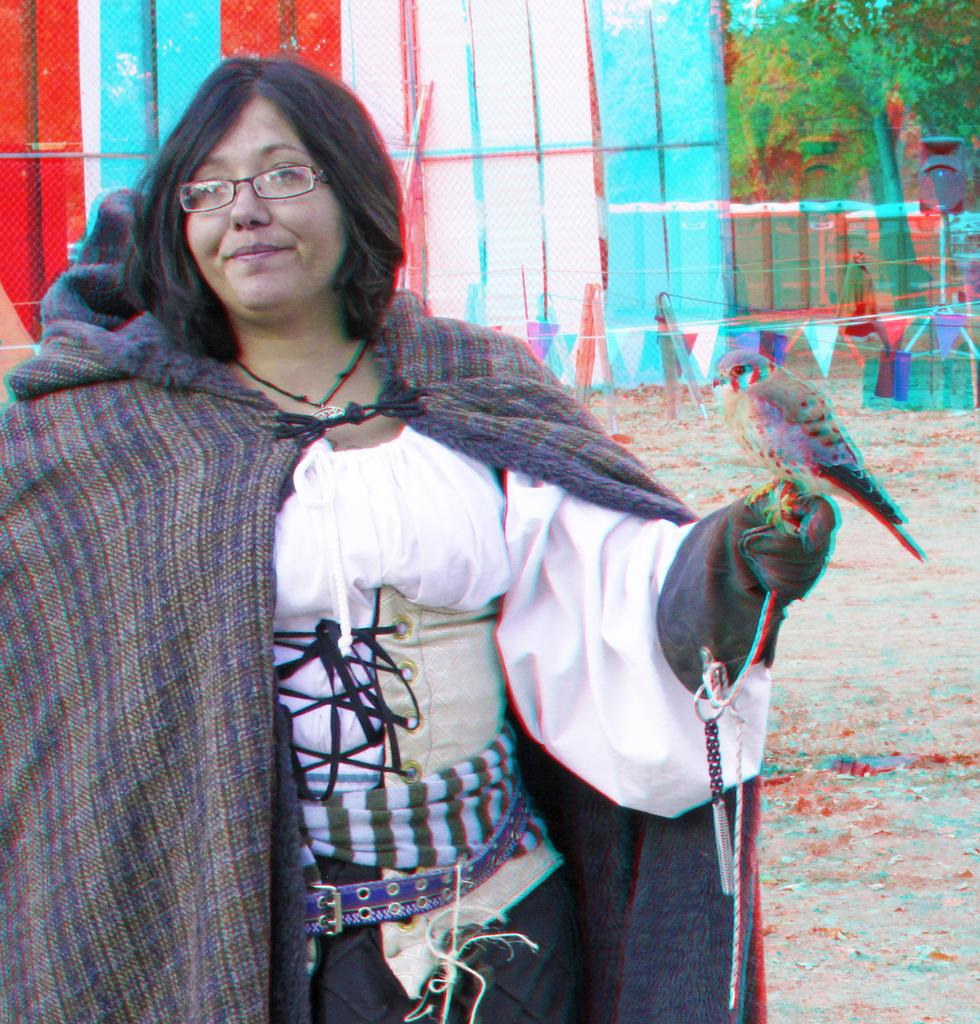What is present in the image? There is a person in the image. Can you describe the person's appearance? The person is wearing clothes and spectacles. What else can be seen in the image? There is a bird on the right side of the image and a tree in the top right of the image. Are there any giants visible in the image? No, there are no giants present in the image. Can you describe the type of cable used by the bird in the image? There is no cable present in the image, as it features a bird and a person with no mention of any cables. 